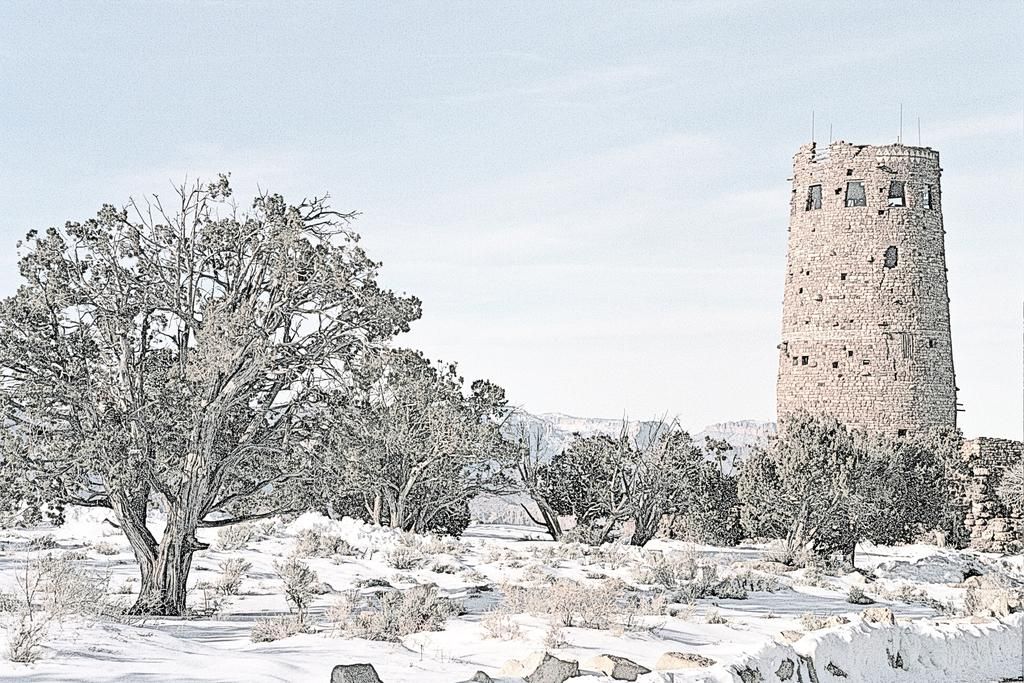What is the main structure in the image? There is a tower in the image. What type of vegetation can be seen in the image? There are trees and plants in the image. How is the ground depicted in the image? The ground is covered with snow in the image. What part of the natural environment is visible in the image? The sky is visible in the image. Can you see any respectful behavior towards the jellyfish in the image? There are no jellyfish present in the image, so it is not possible to observe any behavior towards them. 